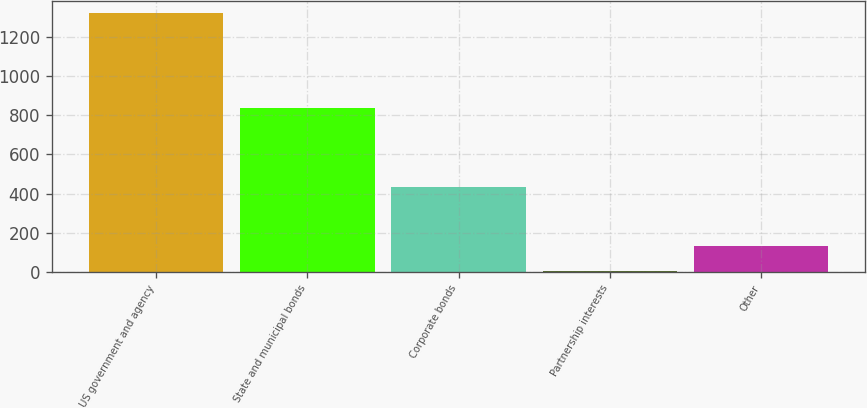Convert chart. <chart><loc_0><loc_0><loc_500><loc_500><bar_chart><fcel>US government and agency<fcel>State and municipal bonds<fcel>Corporate bonds<fcel>Partnership interests<fcel>Other<nl><fcel>1320<fcel>837<fcel>432<fcel>2.06<fcel>133.85<nl></chart> 